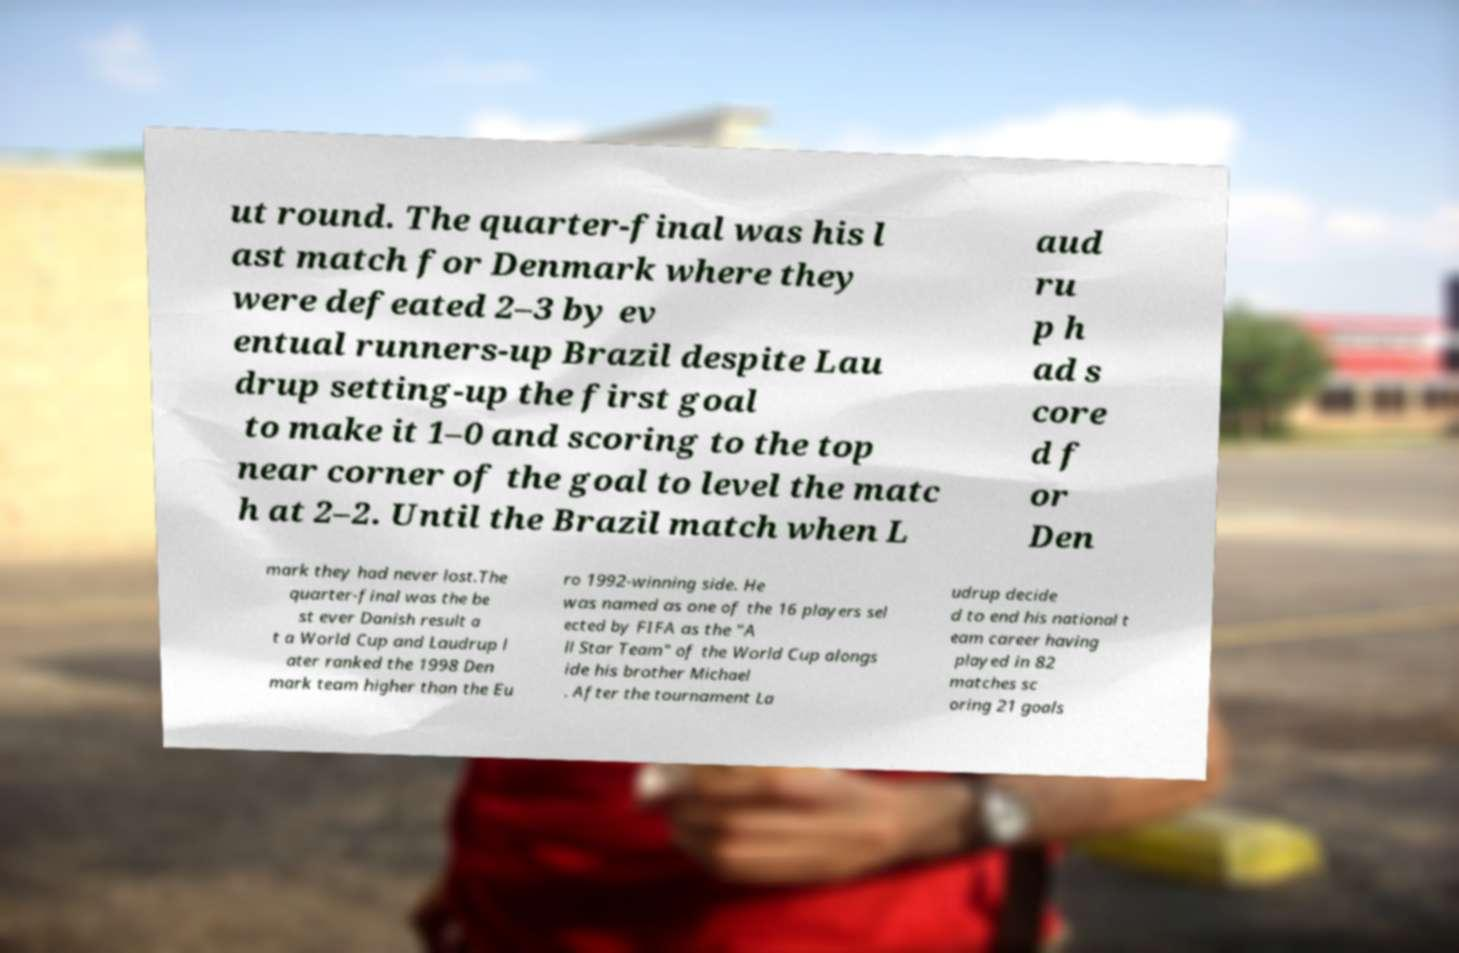Please read and relay the text visible in this image. What does it say? ut round. The quarter-final was his l ast match for Denmark where they were defeated 2–3 by ev entual runners-up Brazil despite Lau drup setting-up the first goal to make it 1–0 and scoring to the top near corner of the goal to level the matc h at 2–2. Until the Brazil match when L aud ru p h ad s core d f or Den mark they had never lost.The quarter-final was the be st ever Danish result a t a World Cup and Laudrup l ater ranked the 1998 Den mark team higher than the Eu ro 1992-winning side. He was named as one of the 16 players sel ected by FIFA as the "A ll Star Team" of the World Cup alongs ide his brother Michael . After the tournament La udrup decide d to end his national t eam career having played in 82 matches sc oring 21 goals 